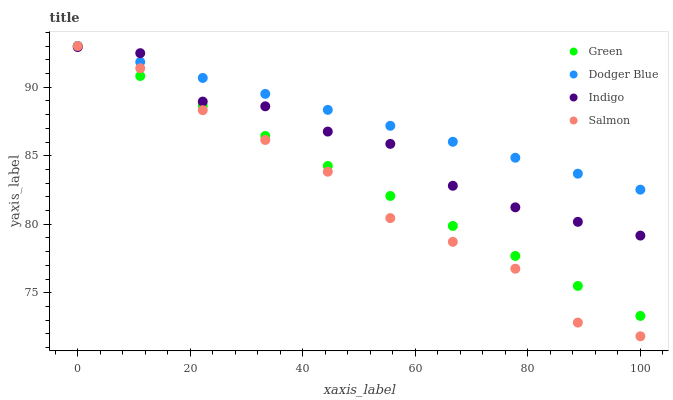Does Salmon have the minimum area under the curve?
Answer yes or no. Yes. Does Dodger Blue have the maximum area under the curve?
Answer yes or no. Yes. Does Green have the minimum area under the curve?
Answer yes or no. No. Does Green have the maximum area under the curve?
Answer yes or no. No. Is Dodger Blue the smoothest?
Answer yes or no. Yes. Is Indigo the roughest?
Answer yes or no. Yes. Is Green the smoothest?
Answer yes or no. No. Is Green the roughest?
Answer yes or no. No. Does Salmon have the lowest value?
Answer yes or no. Yes. Does Green have the lowest value?
Answer yes or no. No. Does Salmon have the highest value?
Answer yes or no. Yes. Does Indigo have the highest value?
Answer yes or no. No. Does Salmon intersect Green?
Answer yes or no. Yes. Is Salmon less than Green?
Answer yes or no. No. Is Salmon greater than Green?
Answer yes or no. No. 